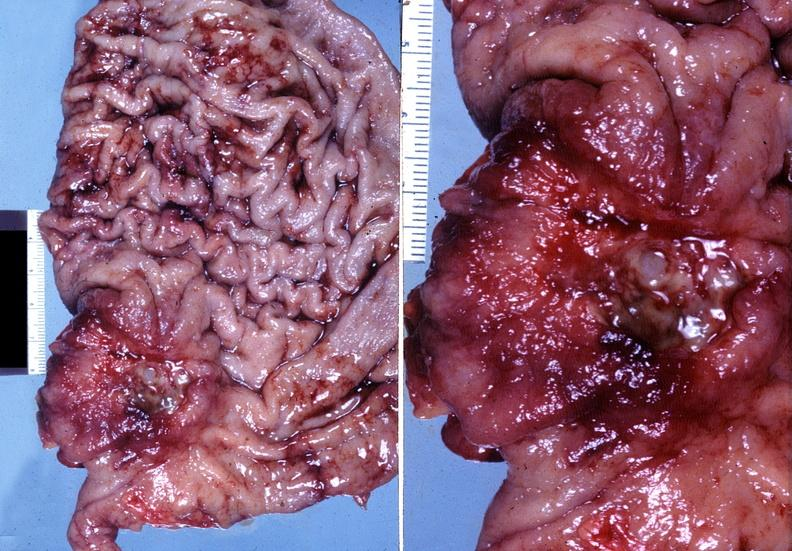what does this image show?
Answer the question using a single word or phrase. Stomach 